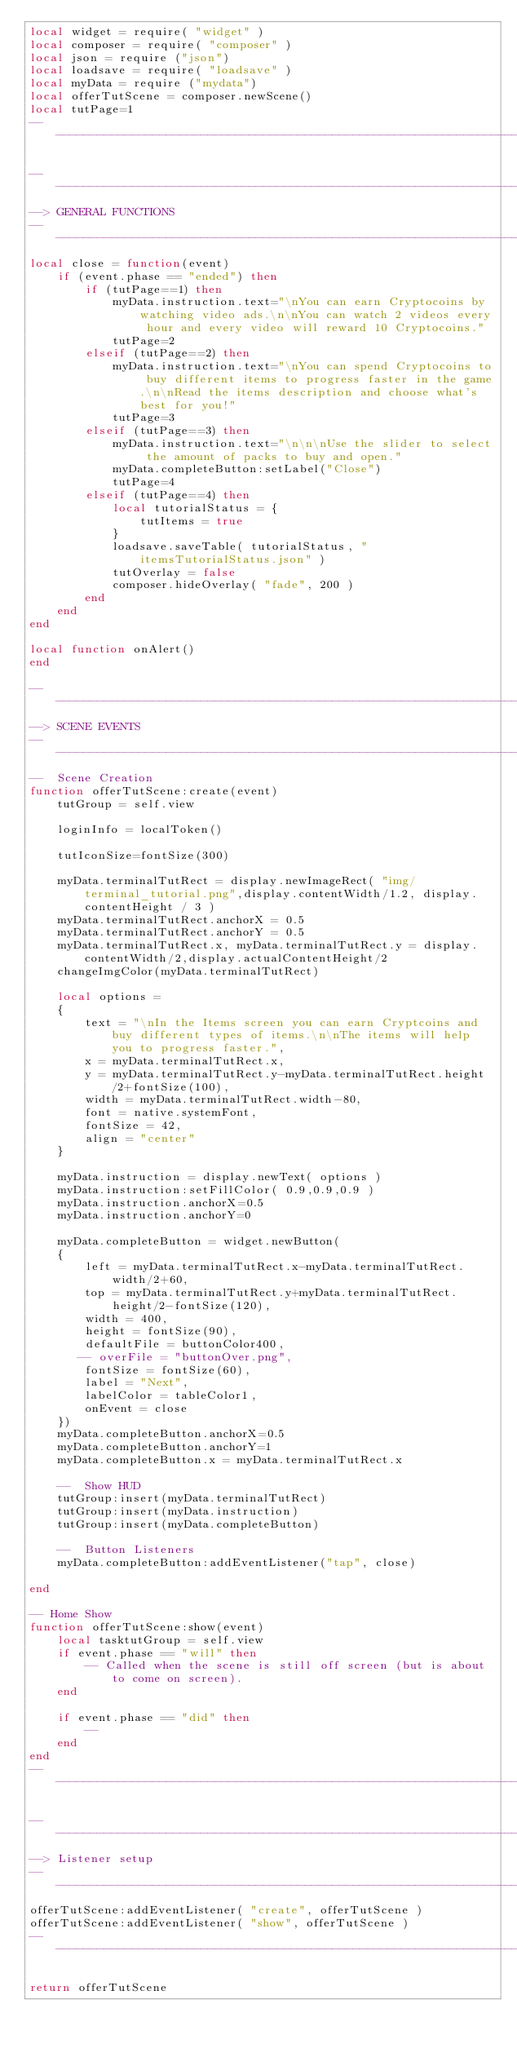Convert code to text. <code><loc_0><loc_0><loc_500><loc_500><_Lua_>local widget = require( "widget" )
local composer = require( "composer" )
local json = require ("json")
local loadsave = require( "loadsave" )
local myData = require ("mydata")
local offerTutScene = composer.newScene()
local tutPage=1
---------------------------------------------------------------------------------

---------------------------------------------------------------------------------
--> GENERAL FUNCTIONS
---------------------------------------------------------------------------------
local close = function(event)
    if (event.phase == "ended") then
        if (tutPage==1) then
            myData.instruction.text="\nYou can earn Cryptocoins by watching video ads.\n\nYou can watch 2 videos every hour and every video will reward 10 Cryptocoins."
            tutPage=2
        elseif (tutPage==2) then
            myData.instruction.text="\nYou can spend Cryptocoins to buy different items to progress faster in the game.\n\nRead the items description and choose what's best for you!"
            tutPage=3
        elseif (tutPage==3) then
            myData.instruction.text="\n\n\nUse the slider to select the amount of packs to buy and open."
            myData.completeButton:setLabel("Close")
            tutPage=4
        elseif (tutPage==4) then
            local tutorialStatus = {
                tutItems = true
            }
            loadsave.saveTable( tutorialStatus, "itemsTutorialStatus.json" )
            tutOverlay = false
            composer.hideOverlay( "fade", 200 )
        end
    end
end

local function onAlert()
end

---------------------------------------------------------------------------------
--> SCENE EVENTS
---------------------------------------------------------------------------------
--  Scene Creation
function offerTutScene:create(event)
    tutGroup = self.view

    loginInfo = localToken()

    tutIconSize=fontSize(300)

    myData.terminalTutRect = display.newImageRect( "img/terminal_tutorial.png",display.contentWidth/1.2, display.contentHeight / 3 )
    myData.terminalTutRect.anchorX = 0.5
    myData.terminalTutRect.anchorY = 0.5
    myData.terminalTutRect.x, myData.terminalTutRect.y = display.contentWidth/2,display.actualContentHeight/2
    changeImgColor(myData.terminalTutRect)

    local options = 
    {
        text = "\nIn the Items screen you can earn Cryptcoins and buy different types of items.\n\nThe items will help you to progress faster.",     
        x = myData.terminalTutRect.x,
        y = myData.terminalTutRect.y-myData.terminalTutRect.height/2+fontSize(100),
        width = myData.terminalTutRect.width-80,
        font = native.systemFont,   
        fontSize = 42,
        align = "center"
    }
     
    myData.instruction = display.newText( options )
    myData.instruction:setFillColor( 0.9,0.9,0.9 )
    myData.instruction.anchorX=0.5
    myData.instruction.anchorY=0

    myData.completeButton = widget.newButton(
    {
        left = myData.terminalTutRect.x-myData.terminalTutRect.width/2+60,
        top = myData.terminalTutRect.y+myData.terminalTutRect.height/2-fontSize(120),
        width = 400,
        height = fontSize(90),
        defaultFile = buttonColor400,
       -- overFile = "buttonOver.png",
        fontSize = fontSize(60),
        label = "Next",
        labelColor = tableColor1,
        onEvent = close
    })
    myData.completeButton.anchorX=0.5
    myData.completeButton.anchorY=1
    myData.completeButton.x = myData.terminalTutRect.x

    --  Show HUD    
    tutGroup:insert(myData.terminalTutRect)
    tutGroup:insert(myData.instruction)
    tutGroup:insert(myData.completeButton)

    --  Button Listeners
    myData.completeButton:addEventListener("tap", close)

end

-- Home Show
function offerTutScene:show(event)
    local tasktutGroup = self.view
    if event.phase == "will" then
        -- Called when the scene is still off screen (but is about to come on screen).
    end

    if event.phase == "did" then
        --      
    end
end
---------------------------------------------------------------------------------

---------------------------------------------------------------------------------
--> Listener setup
---------------------------------------------------------------------------------
offerTutScene:addEventListener( "create", offerTutScene )
offerTutScene:addEventListener( "show", offerTutScene )
---------------------------------------------------------------------------------

return offerTutScene</code> 